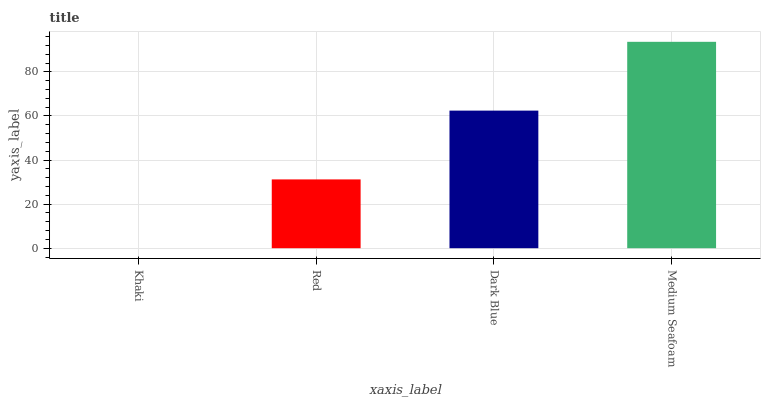Is Khaki the minimum?
Answer yes or no. Yes. Is Medium Seafoam the maximum?
Answer yes or no. Yes. Is Red the minimum?
Answer yes or no. No. Is Red the maximum?
Answer yes or no. No. Is Red greater than Khaki?
Answer yes or no. Yes. Is Khaki less than Red?
Answer yes or no. Yes. Is Khaki greater than Red?
Answer yes or no. No. Is Red less than Khaki?
Answer yes or no. No. Is Dark Blue the high median?
Answer yes or no. Yes. Is Red the low median?
Answer yes or no. Yes. Is Khaki the high median?
Answer yes or no. No. Is Medium Seafoam the low median?
Answer yes or no. No. 